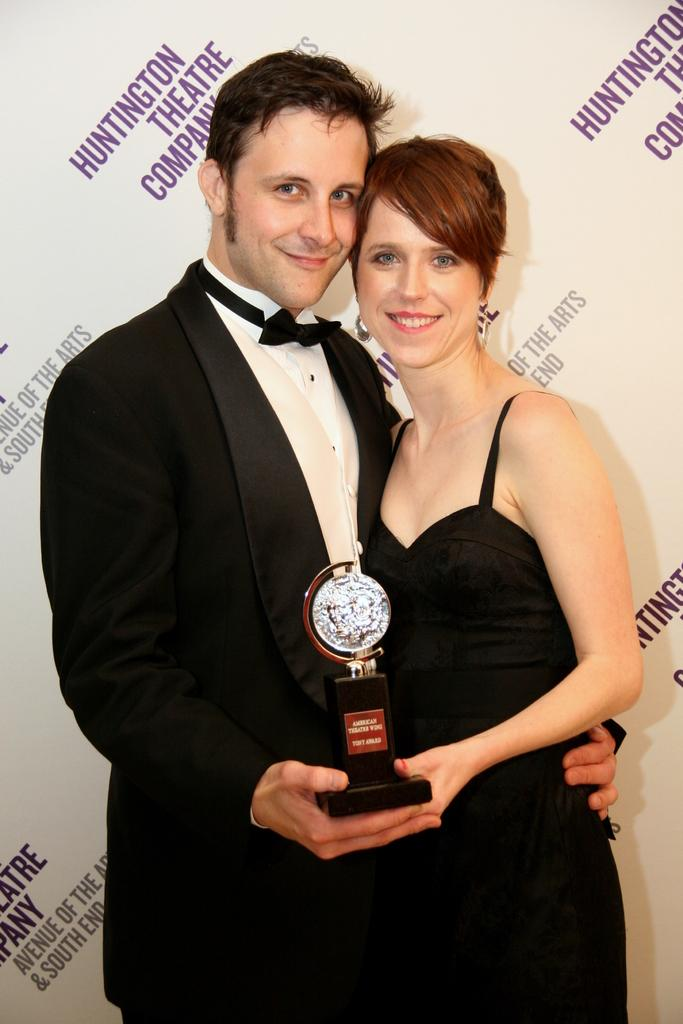<image>
Give a short and clear explanation of the subsequent image. Two people pose with an award at a Huntington Theatre Company event. 